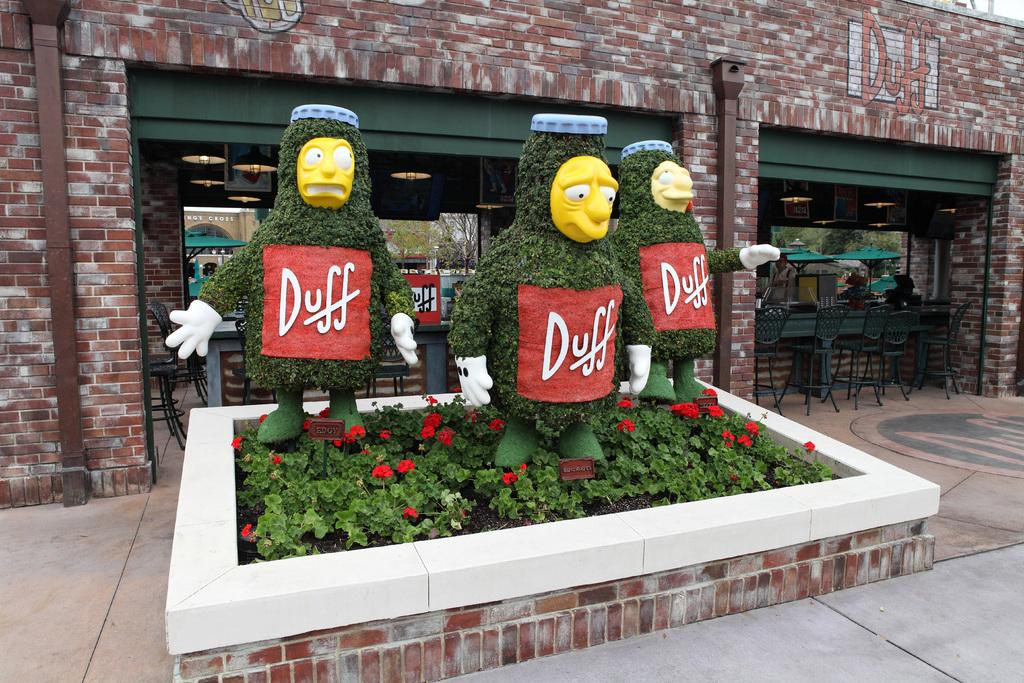<image>
Give a short and clear explanation of the subsequent image. Three bottles of Duff beer are displayed in a planter in front of a bar. 